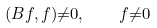<formula> <loc_0><loc_0><loc_500><loc_500>( B f , f ) { \ne } 0 , \quad f { \ne } 0</formula> 